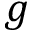Convert formula to latex. <formula><loc_0><loc_0><loc_500><loc_500>g</formula> 